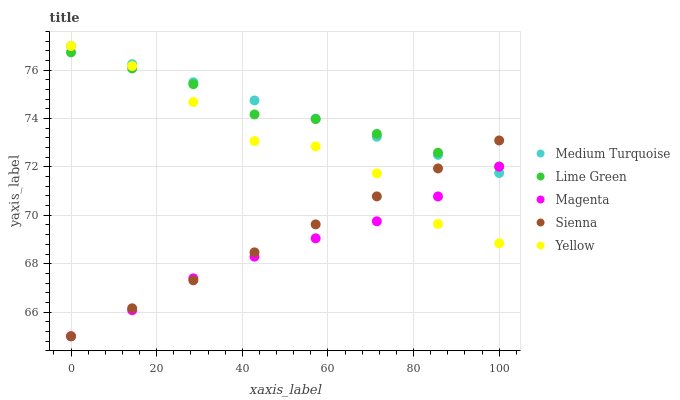Does Magenta have the minimum area under the curve?
Answer yes or no. Yes. Does Medium Turquoise have the maximum area under the curve?
Answer yes or no. Yes. Does Lime Green have the minimum area under the curve?
Answer yes or no. No. Does Lime Green have the maximum area under the curve?
Answer yes or no. No. Is Sienna the smoothest?
Answer yes or no. Yes. Is Yellow the roughest?
Answer yes or no. Yes. Is Magenta the smoothest?
Answer yes or no. No. Is Magenta the roughest?
Answer yes or no. No. Does Sienna have the lowest value?
Answer yes or no. Yes. Does Lime Green have the lowest value?
Answer yes or no. No. Does Medium Turquoise have the highest value?
Answer yes or no. Yes. Does Lime Green have the highest value?
Answer yes or no. No. Is Magenta less than Lime Green?
Answer yes or no. Yes. Is Lime Green greater than Magenta?
Answer yes or no. Yes. Does Medium Turquoise intersect Yellow?
Answer yes or no. Yes. Is Medium Turquoise less than Yellow?
Answer yes or no. No. Is Medium Turquoise greater than Yellow?
Answer yes or no. No. Does Magenta intersect Lime Green?
Answer yes or no. No. 